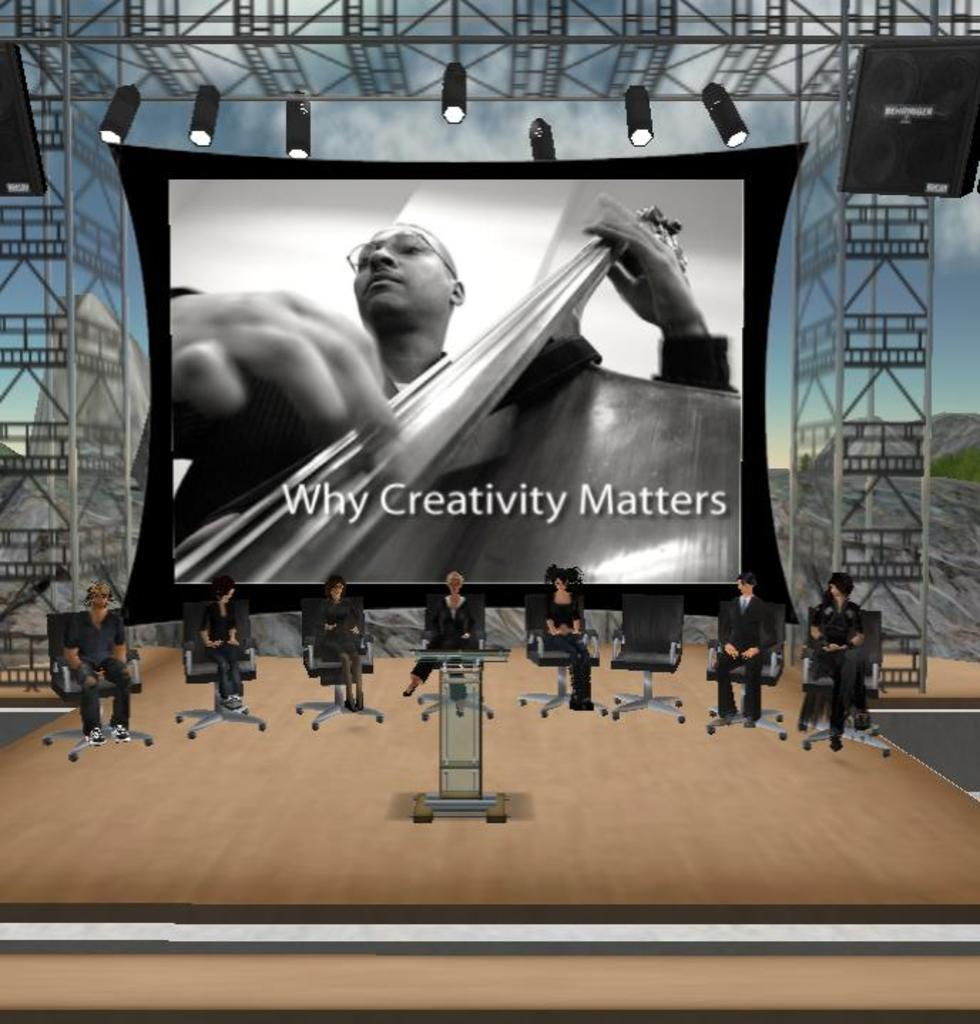What is the main subject of the image? The main subject of the image is a screen. What is happening on the screen? A man is playing a musical instrument on the screen. How is the man playing the instrument? The man is using his hands to play the instrument. What else can be seen in the image besides the screen? There are lights, chairs, a podium, speakers, and some persons visible in the image. Where is the faucet located in the image? There is no faucet present in the image. What type of bear can be seen interacting with the musical instrument on the screen? There is no bear present in the image; it features a man playing the instrument. 